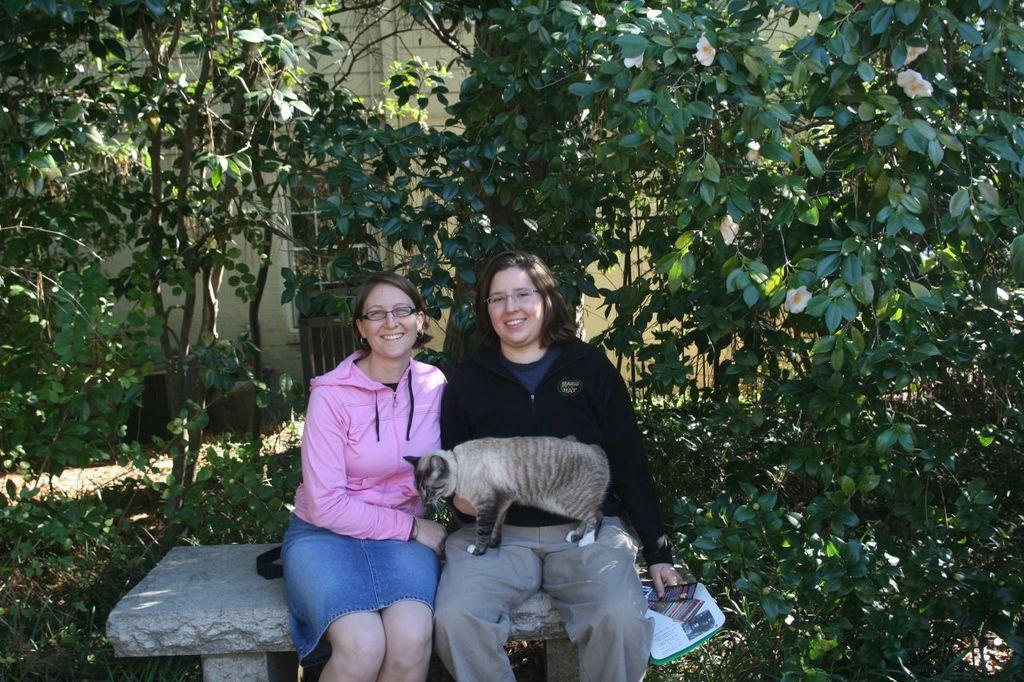Describe this image in one or two sentences. In this picture we can see two women are seated on the bench, and the right side woman is holding some papers in her hand and a cat. In the background we can see couple of trees and a building. 